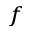Convert formula to latex. <formula><loc_0><loc_0><loc_500><loc_500>^ { f }</formula> 